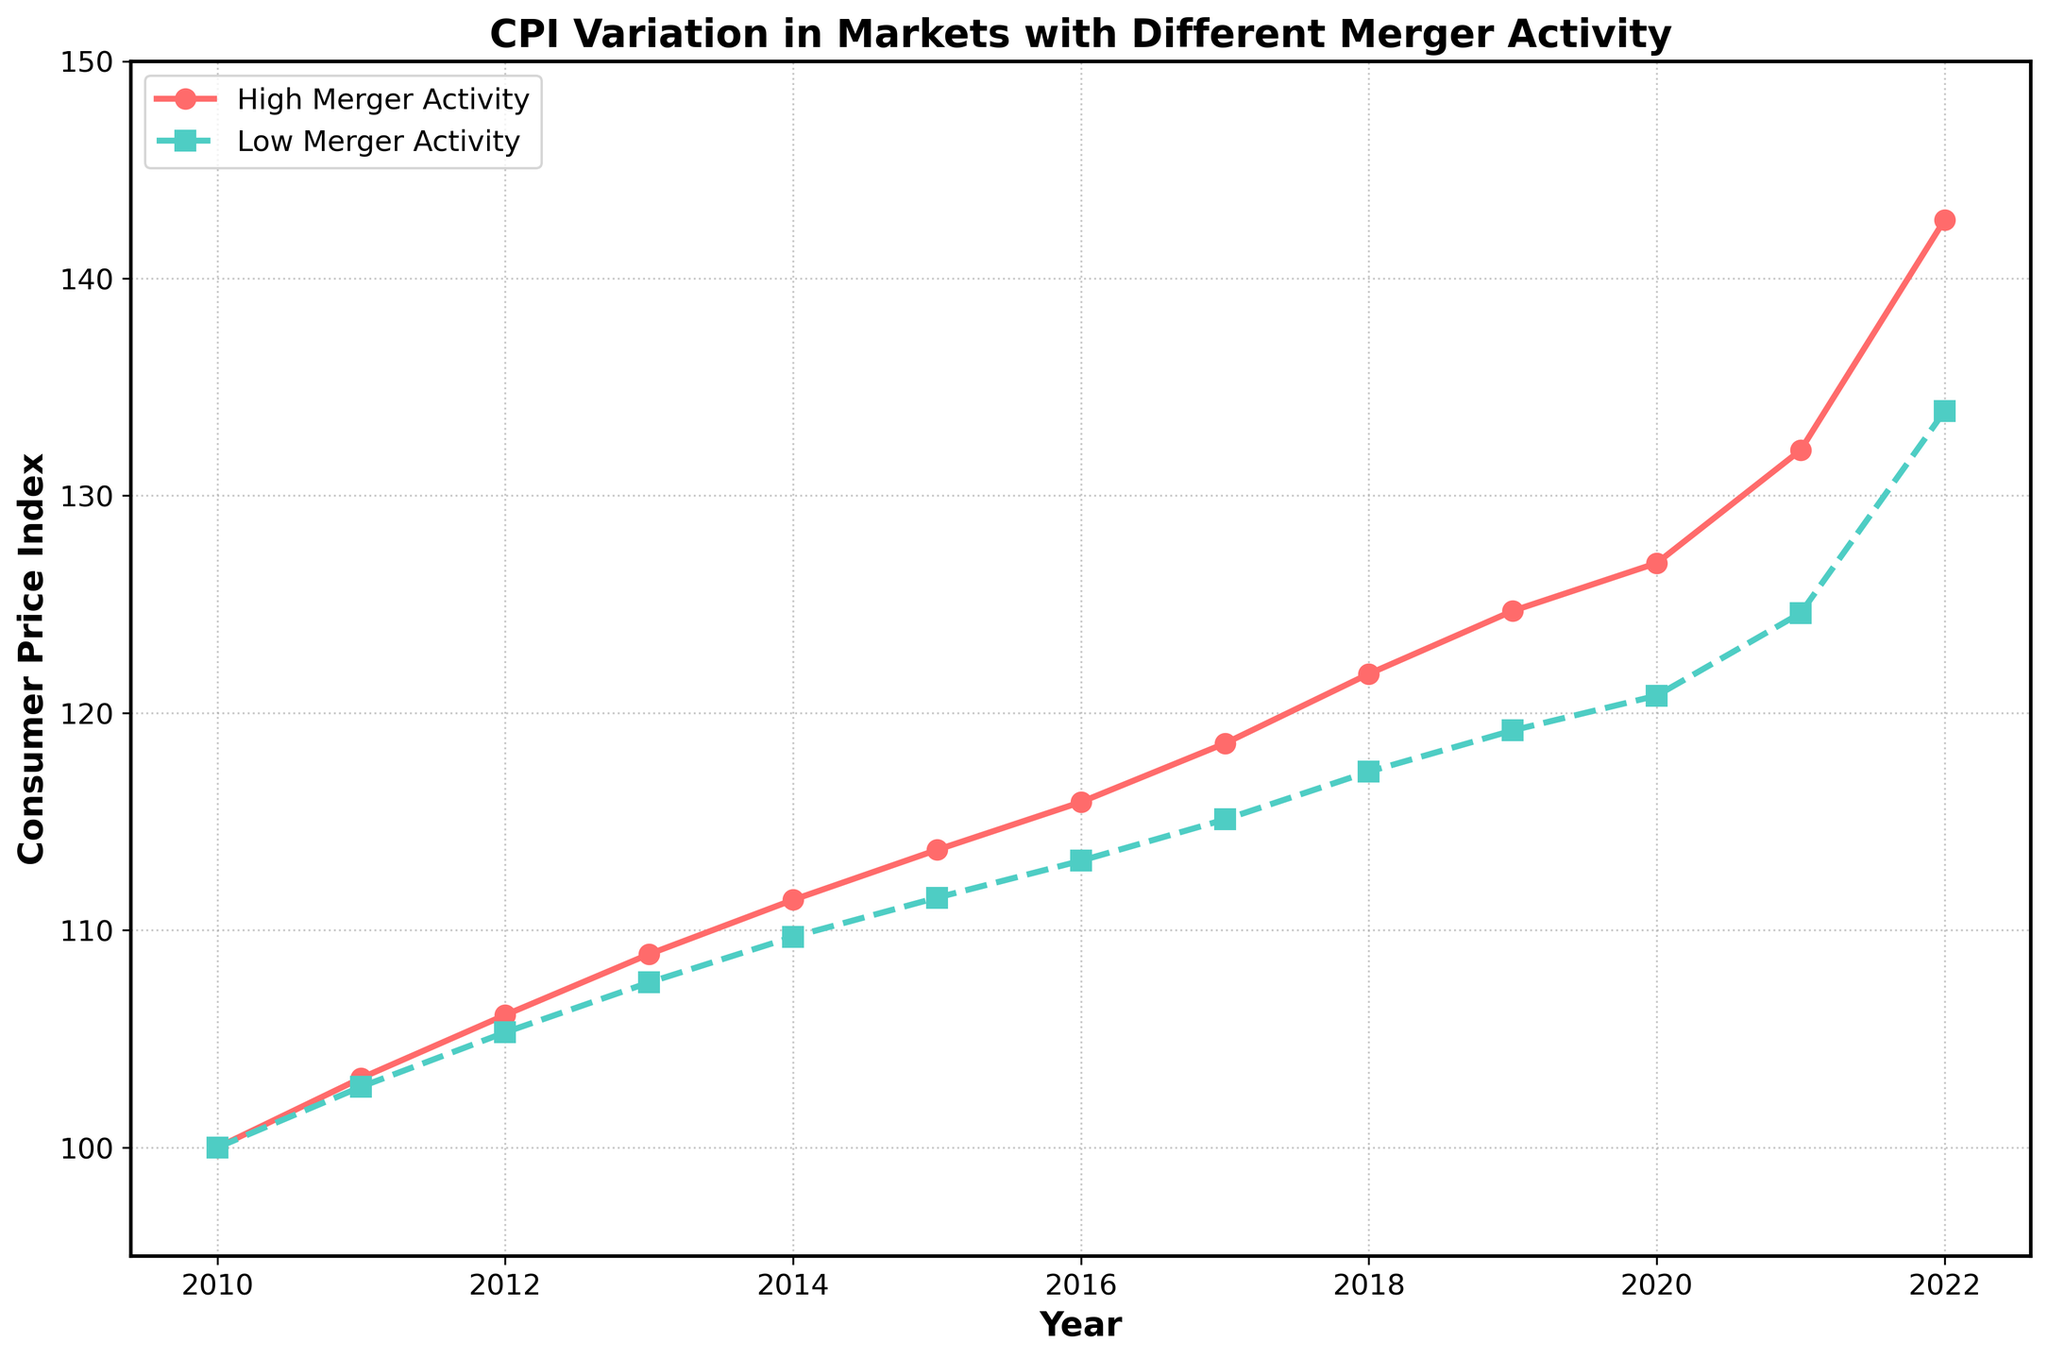What trend can be observed in the CPI for markets with high merger activity from 2010 to 2022? Looking at the red line representing high merger activity, the CPI increases steadily from 100 in 2010 to 142.7 in 2022, indicating a consistent upward trend.
Answer: Increasing trend What is the difference in CPI between markets with high and low merger activity in 2022? The CPI for high merger activity in 2022 is 142.7, while for low merger activity, it is 133.9. The difference is 142.7 - 133.9 = 8.8.
Answer: 8.8 In which year did the markets with low merger activity surpass a CPI of 110 for the first time? Observing the green line for markets with low merger activity, the CPI surpassed 110 in 2015 with a value of 111.5.
Answer: 2015 Comparing the CPI values for 2020, which type of market activity has the lower CPI, and by how much? In 2020, the CPI for high merger activity is 126.9, and for low merger activity, it is 120.8. The markets with low merger activity have a lower CPI by 126.9 - 120.8 = 6.1.
Answer: Low merger activity by 6.1 What is the average CPI for markets with high merger activity from 2010 to 2022? Computing the average CPI for high merger activity involves summing the values from 2010 to 2022 and dividing by the number of years. (100.0 + 103.2 + 106.1 + 108.9 + 111.4 + 113.7 + 115.9 + 118.6 + 121.8 + 124.7 + 126.9 + 132.1 + 142.7) / 13 = 117.22.
Answer: 117.22 By how much did the CPI for markets with low merger activity increase from 2010 to 2015? In 2010, the CPI for low merger activity was 100.0, and in 2015, it was 111.5. The increase is 111.5 - 100.0 = 11.5.
Answer: 11.5 Which year shows the highest annual increase in CPI for markets with high merger activity? The highest annual increase can be observed by checking the differences year over year. The largest jump is from 2021 (132.1) to 2022 (142.7), with an increase of 142.7 - 132.1 = 10.6.
Answer: 2022 Is there any year where the CPI for markets with high merger activity is less than that for low merger activity? By examining both lines, we find that in all years from 2010 to 2022, the CPI for high merger activity is always higher than for low merger activity, so the answer is no.
Answer: No 